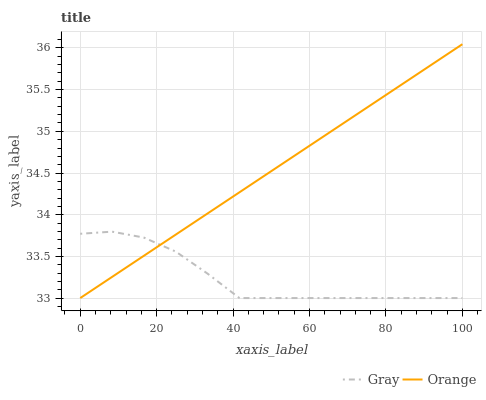Does Gray have the minimum area under the curve?
Answer yes or no. Yes. Does Orange have the maximum area under the curve?
Answer yes or no. Yes. Does Gray have the maximum area under the curve?
Answer yes or no. No. Is Orange the smoothest?
Answer yes or no. Yes. Is Gray the roughest?
Answer yes or no. Yes. Is Gray the smoothest?
Answer yes or no. No. Does Orange have the lowest value?
Answer yes or no. Yes. Does Orange have the highest value?
Answer yes or no. Yes. Does Gray have the highest value?
Answer yes or no. No. Does Gray intersect Orange?
Answer yes or no. Yes. Is Gray less than Orange?
Answer yes or no. No. Is Gray greater than Orange?
Answer yes or no. No. 